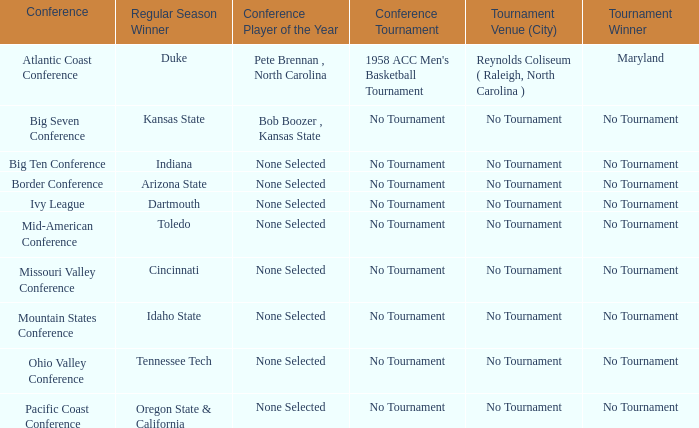Who won the regular season when Missouri Valley Conference took place? Cincinnati. 